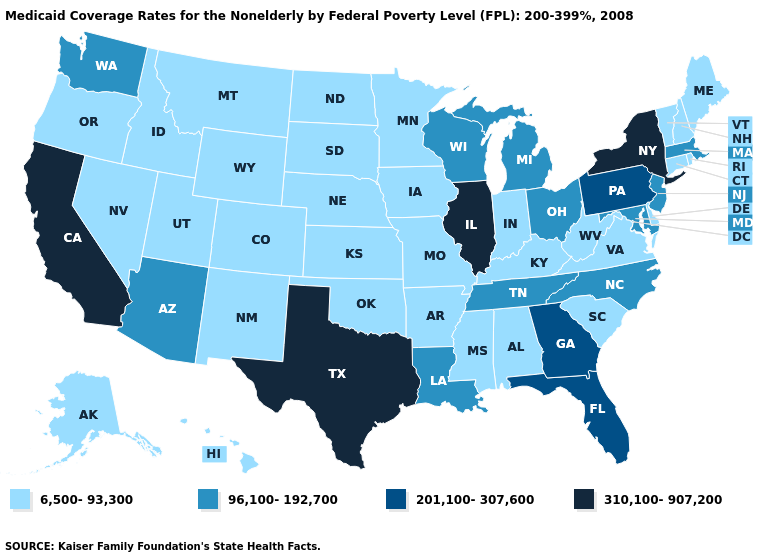Among the states that border South Dakota , which have the highest value?
Quick response, please. Iowa, Minnesota, Montana, Nebraska, North Dakota, Wyoming. Name the states that have a value in the range 201,100-307,600?
Keep it brief. Florida, Georgia, Pennsylvania. Which states have the lowest value in the USA?
Be succinct. Alabama, Alaska, Arkansas, Colorado, Connecticut, Delaware, Hawaii, Idaho, Indiana, Iowa, Kansas, Kentucky, Maine, Minnesota, Mississippi, Missouri, Montana, Nebraska, Nevada, New Hampshire, New Mexico, North Dakota, Oklahoma, Oregon, Rhode Island, South Carolina, South Dakota, Utah, Vermont, Virginia, West Virginia, Wyoming. What is the highest value in states that border Tennessee?
Concise answer only. 201,100-307,600. Name the states that have a value in the range 310,100-907,200?
Write a very short answer. California, Illinois, New York, Texas. Among the states that border Alabama , which have the highest value?
Be succinct. Florida, Georgia. Is the legend a continuous bar?
Write a very short answer. No. Name the states that have a value in the range 6,500-93,300?
Keep it brief. Alabama, Alaska, Arkansas, Colorado, Connecticut, Delaware, Hawaii, Idaho, Indiana, Iowa, Kansas, Kentucky, Maine, Minnesota, Mississippi, Missouri, Montana, Nebraska, Nevada, New Hampshire, New Mexico, North Dakota, Oklahoma, Oregon, Rhode Island, South Carolina, South Dakota, Utah, Vermont, Virginia, West Virginia, Wyoming. Among the states that border Delaware , which have the lowest value?
Be succinct. Maryland, New Jersey. What is the highest value in the South ?
Short answer required. 310,100-907,200. Does Tennessee have the lowest value in the South?
Give a very brief answer. No. Name the states that have a value in the range 310,100-907,200?
Short answer required. California, Illinois, New York, Texas. What is the highest value in the USA?
Write a very short answer. 310,100-907,200. What is the value of New Hampshire?
Concise answer only. 6,500-93,300. What is the highest value in states that border Iowa?
Answer briefly. 310,100-907,200. 